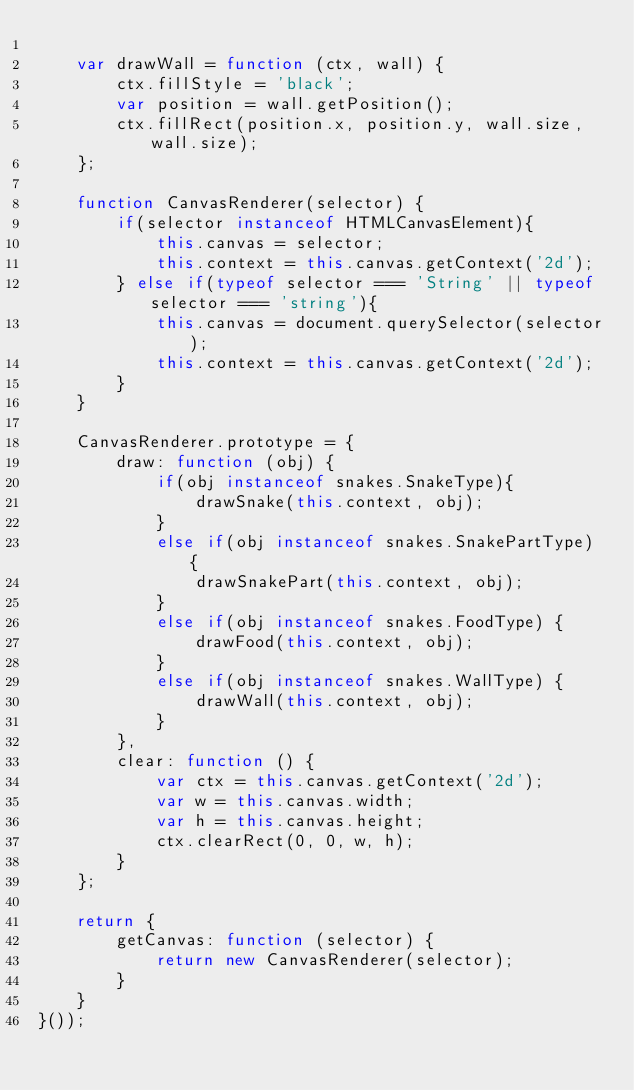Convert code to text. <code><loc_0><loc_0><loc_500><loc_500><_JavaScript_>
    var drawWall = function (ctx, wall) {
        ctx.fillStyle = 'black';
        var position = wall.getPosition();
        ctx.fillRect(position.x, position.y, wall.size, wall.size);
    };

    function CanvasRenderer(selector) {
        if(selector instanceof HTMLCanvasElement){
            this.canvas = selector;
            this.context = this.canvas.getContext('2d');
        } else if(typeof selector === 'String' || typeof selector === 'string'){
            this.canvas = document.querySelector(selector);
            this.context = this.canvas.getContext('2d');
        }
    }

    CanvasRenderer.prototype = {
        draw: function (obj) {
            if(obj instanceof snakes.SnakeType){
                drawSnake(this.context, obj);
            }
            else if(obj instanceof snakes.SnakePartType) {
                drawSnakePart(this.context, obj);
            }
            else if(obj instanceof snakes.FoodType) {
                drawFood(this.context, obj);
            }
            else if(obj instanceof snakes.WallType) {
                drawWall(this.context, obj);
            }
        },
        clear: function () {
            var ctx = this.canvas.getContext('2d');
            var w = this.canvas.width;
            var h = this.canvas.height;
            ctx.clearRect(0, 0, w, h);
        }
    };

    return {
        getCanvas: function (selector) {
            return new CanvasRenderer(selector);
        }
    }
}());</code> 